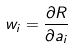Convert formula to latex. <formula><loc_0><loc_0><loc_500><loc_500>w _ { i } = \frac { \partial R } { \partial a _ { i } }</formula> 